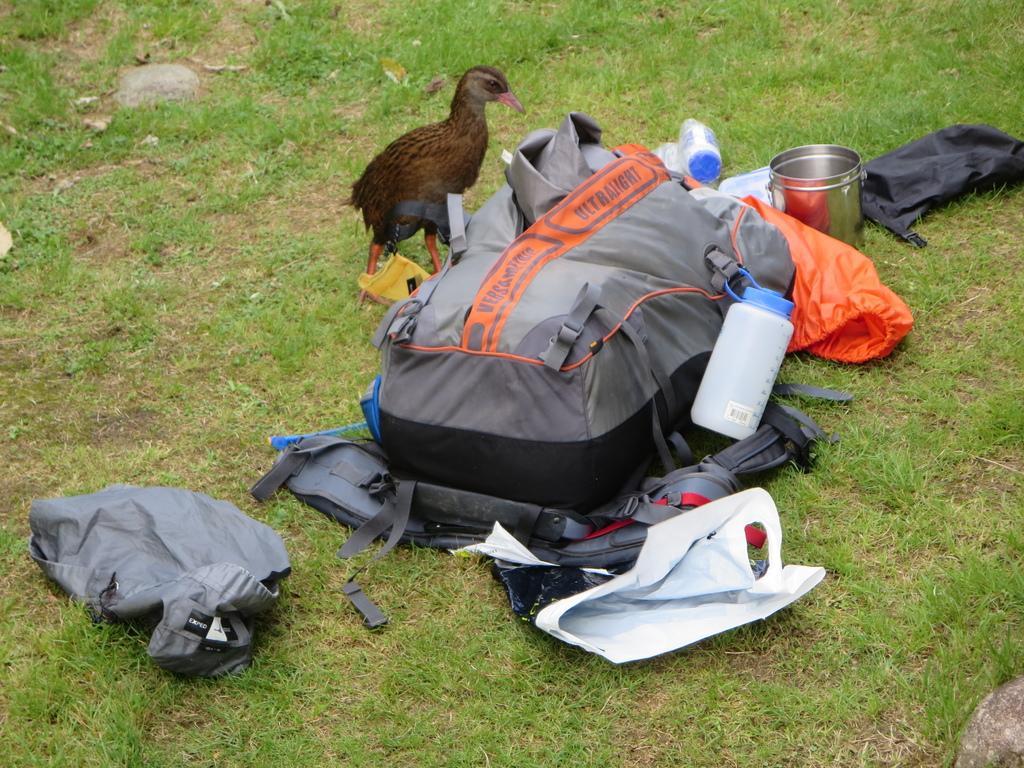In one or two sentences, can you explain what this image depicts? In this image I can see a bird, a bag, a bottle and a utensil. 